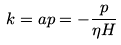Convert formula to latex. <formula><loc_0><loc_0><loc_500><loc_500>k = a p = - \frac { p } { \eta H }</formula> 